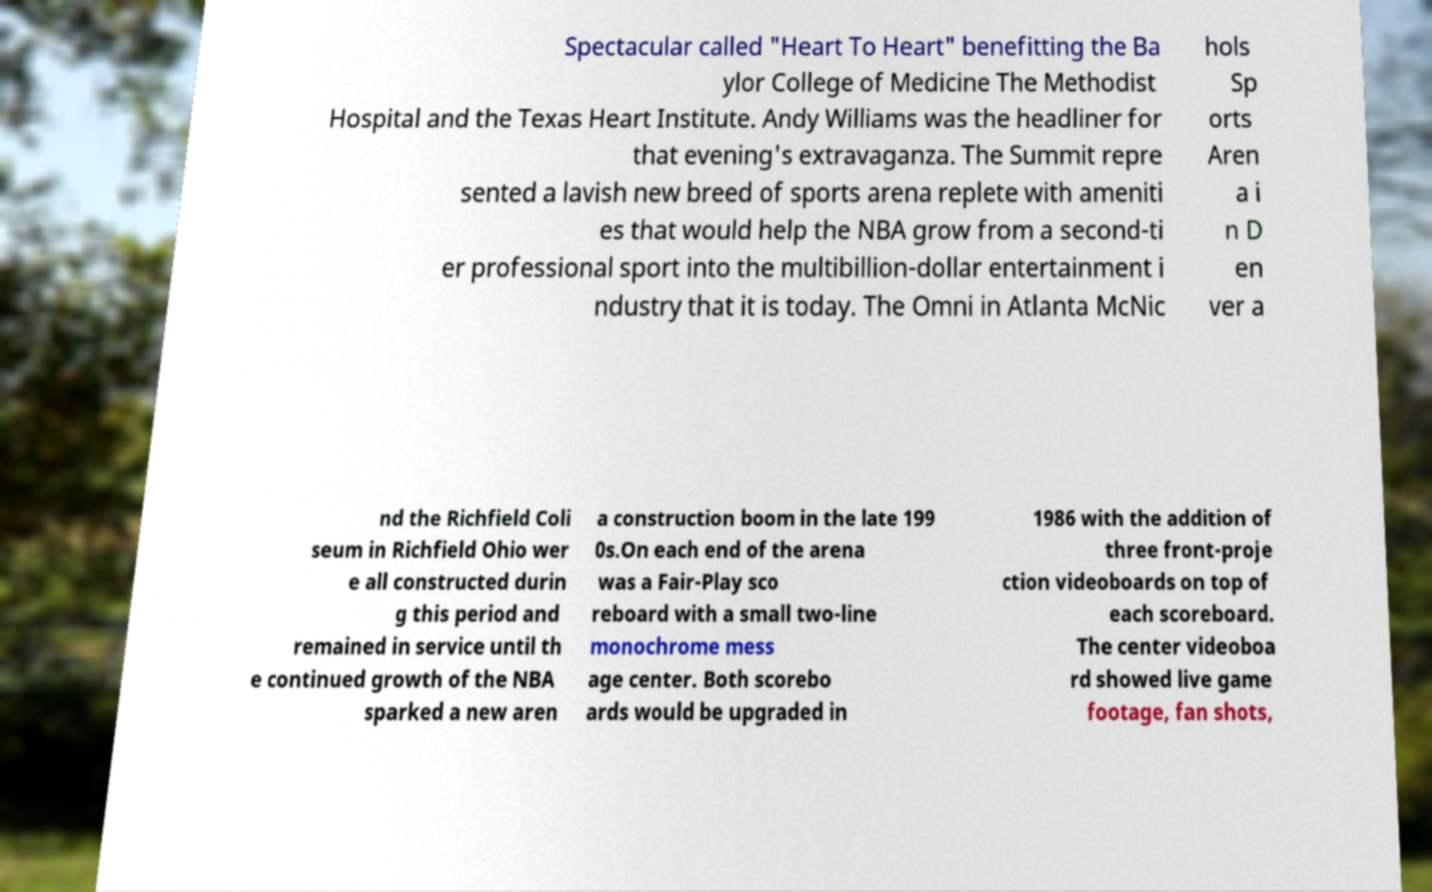Could you assist in decoding the text presented in this image and type it out clearly? Spectacular called "Heart To Heart" benefitting the Ba ylor College of Medicine The Methodist Hospital and the Texas Heart Institute. Andy Williams was the headliner for that evening's extravaganza. The Summit repre sented a lavish new breed of sports arena replete with ameniti es that would help the NBA grow from a second-ti er professional sport into the multibillion-dollar entertainment i ndustry that it is today. The Omni in Atlanta McNic hols Sp orts Aren a i n D en ver a nd the Richfield Coli seum in Richfield Ohio wer e all constructed durin g this period and remained in service until th e continued growth of the NBA sparked a new aren a construction boom in the late 199 0s.On each end of the arena was a Fair-Play sco reboard with a small two-line monochrome mess age center. Both scorebo ards would be upgraded in 1986 with the addition of three front-proje ction videoboards on top of each scoreboard. The center videoboa rd showed live game footage, fan shots, 